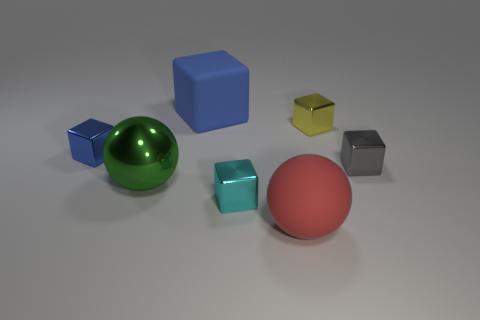Subtract 2 cubes. How many cubes are left? 3 Subtract all big rubber blocks. How many blocks are left? 4 Subtract all gray blocks. How many blocks are left? 4 Add 3 cyan shiny cubes. How many objects exist? 10 Subtract all red blocks. Subtract all purple spheres. How many blocks are left? 5 Subtract all spheres. How many objects are left? 5 Subtract all green metal objects. Subtract all red matte spheres. How many objects are left? 5 Add 1 small yellow things. How many small yellow things are left? 2 Add 1 large red cylinders. How many large red cylinders exist? 1 Subtract 0 red blocks. How many objects are left? 7 